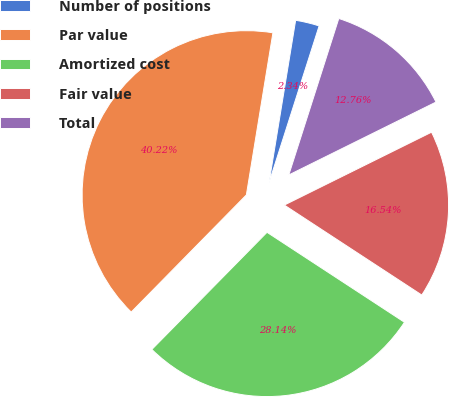Convert chart. <chart><loc_0><loc_0><loc_500><loc_500><pie_chart><fcel>Number of positions<fcel>Par value<fcel>Amortized cost<fcel>Fair value<fcel>Total<nl><fcel>2.34%<fcel>40.22%<fcel>28.14%<fcel>16.54%<fcel>12.76%<nl></chart> 